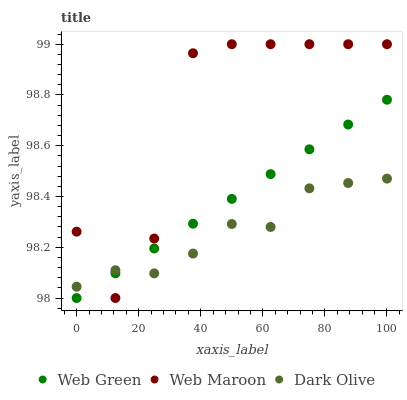Does Dark Olive have the minimum area under the curve?
Answer yes or no. Yes. Does Web Maroon have the maximum area under the curve?
Answer yes or no. Yes. Does Web Green have the minimum area under the curve?
Answer yes or no. No. Does Web Green have the maximum area under the curve?
Answer yes or no. No. Is Web Green the smoothest?
Answer yes or no. Yes. Is Web Maroon the roughest?
Answer yes or no. Yes. Is Web Maroon the smoothest?
Answer yes or no. No. Is Web Green the roughest?
Answer yes or no. No. Does Web Green have the lowest value?
Answer yes or no. Yes. Does Web Maroon have the lowest value?
Answer yes or no. No. Does Web Maroon have the highest value?
Answer yes or no. Yes. Does Web Green have the highest value?
Answer yes or no. No. Does Web Maroon intersect Dark Olive?
Answer yes or no. Yes. Is Web Maroon less than Dark Olive?
Answer yes or no. No. Is Web Maroon greater than Dark Olive?
Answer yes or no. No. 